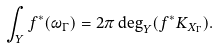Convert formula to latex. <formula><loc_0><loc_0><loc_500><loc_500>\int _ { Y } f ^ { * } ( \omega _ { \Gamma } ) = 2 \pi \deg _ { Y } ( f ^ { * } K _ { X _ { \Gamma } } ) .</formula> 